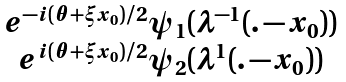Convert formula to latex. <formula><loc_0><loc_0><loc_500><loc_500>\begin{matrix} e ^ { - i ( \theta + \xi x _ { 0 } ) / 2 } \psi _ { 1 } ( \lambda ^ { - 1 } ( . - x _ { 0 } ) ) \\ e ^ { i ( \theta + \xi x _ { 0 } ) / 2 } \psi _ { 2 } ( \lambda ^ { 1 } ( . - x _ { 0 } ) ) \end{matrix}</formula> 